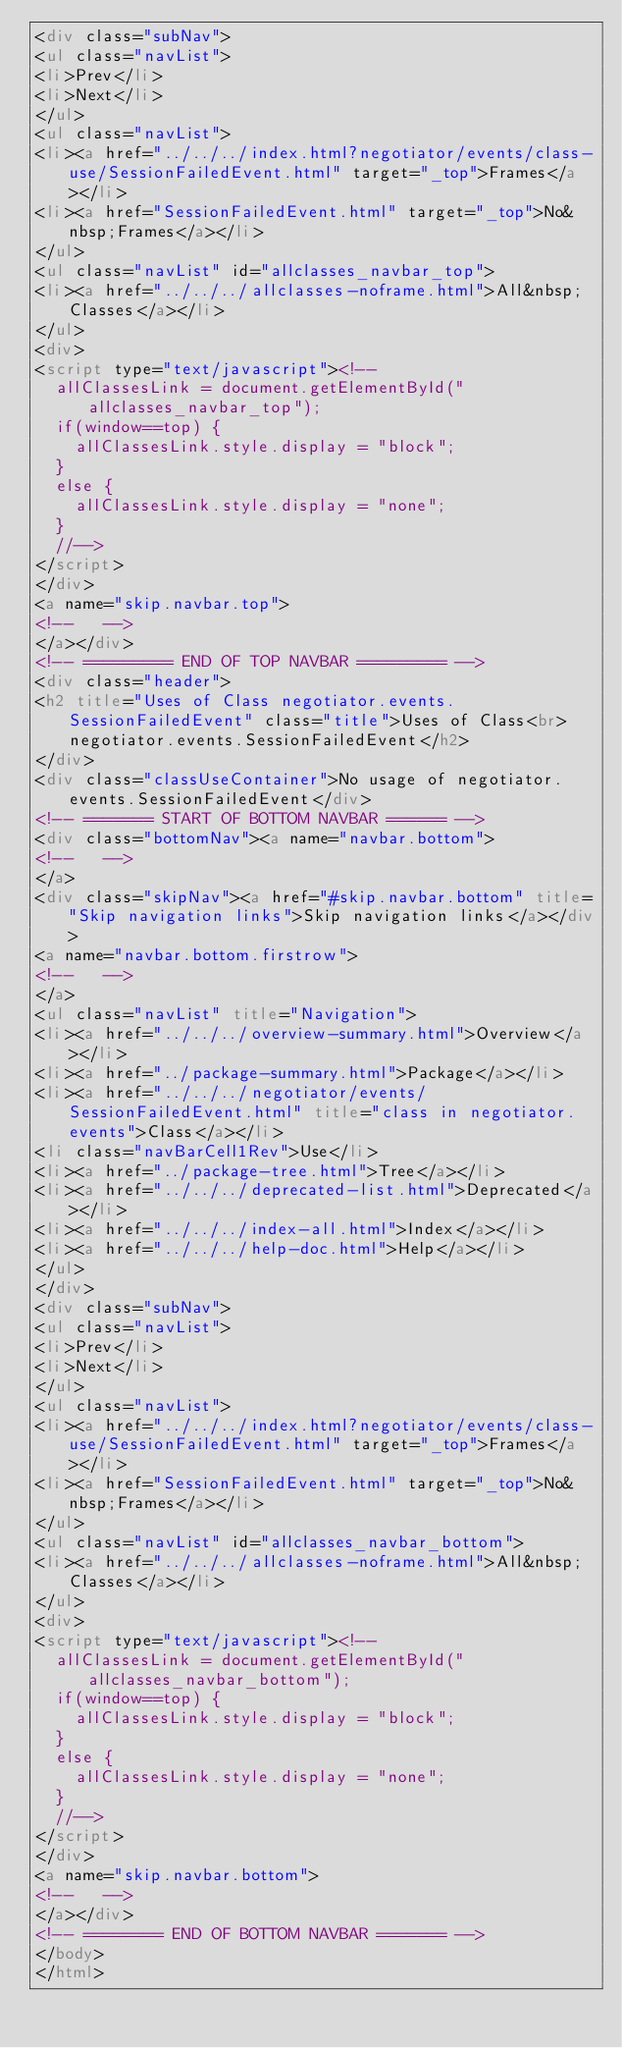Convert code to text. <code><loc_0><loc_0><loc_500><loc_500><_HTML_><div class="subNav">
<ul class="navList">
<li>Prev</li>
<li>Next</li>
</ul>
<ul class="navList">
<li><a href="../../../index.html?negotiator/events/class-use/SessionFailedEvent.html" target="_top">Frames</a></li>
<li><a href="SessionFailedEvent.html" target="_top">No&nbsp;Frames</a></li>
</ul>
<ul class="navList" id="allclasses_navbar_top">
<li><a href="../../../allclasses-noframe.html">All&nbsp;Classes</a></li>
</ul>
<div>
<script type="text/javascript"><!--
  allClassesLink = document.getElementById("allclasses_navbar_top");
  if(window==top) {
    allClassesLink.style.display = "block";
  }
  else {
    allClassesLink.style.display = "none";
  }
  //-->
</script>
</div>
<a name="skip.navbar.top">
<!--   -->
</a></div>
<!-- ========= END OF TOP NAVBAR ========= -->
<div class="header">
<h2 title="Uses of Class negotiator.events.SessionFailedEvent" class="title">Uses of Class<br>negotiator.events.SessionFailedEvent</h2>
</div>
<div class="classUseContainer">No usage of negotiator.events.SessionFailedEvent</div>
<!-- ======= START OF BOTTOM NAVBAR ====== -->
<div class="bottomNav"><a name="navbar.bottom">
<!--   -->
</a>
<div class="skipNav"><a href="#skip.navbar.bottom" title="Skip navigation links">Skip navigation links</a></div>
<a name="navbar.bottom.firstrow">
<!--   -->
</a>
<ul class="navList" title="Navigation">
<li><a href="../../../overview-summary.html">Overview</a></li>
<li><a href="../package-summary.html">Package</a></li>
<li><a href="../../../negotiator/events/SessionFailedEvent.html" title="class in negotiator.events">Class</a></li>
<li class="navBarCell1Rev">Use</li>
<li><a href="../package-tree.html">Tree</a></li>
<li><a href="../../../deprecated-list.html">Deprecated</a></li>
<li><a href="../../../index-all.html">Index</a></li>
<li><a href="../../../help-doc.html">Help</a></li>
</ul>
</div>
<div class="subNav">
<ul class="navList">
<li>Prev</li>
<li>Next</li>
</ul>
<ul class="navList">
<li><a href="../../../index.html?negotiator/events/class-use/SessionFailedEvent.html" target="_top">Frames</a></li>
<li><a href="SessionFailedEvent.html" target="_top">No&nbsp;Frames</a></li>
</ul>
<ul class="navList" id="allclasses_navbar_bottom">
<li><a href="../../../allclasses-noframe.html">All&nbsp;Classes</a></li>
</ul>
<div>
<script type="text/javascript"><!--
  allClassesLink = document.getElementById("allclasses_navbar_bottom");
  if(window==top) {
    allClassesLink.style.display = "block";
  }
  else {
    allClassesLink.style.display = "none";
  }
  //-->
</script>
</div>
<a name="skip.navbar.bottom">
<!--   -->
</a></div>
<!-- ======== END OF BOTTOM NAVBAR ======= -->
</body>
</html>
</code> 